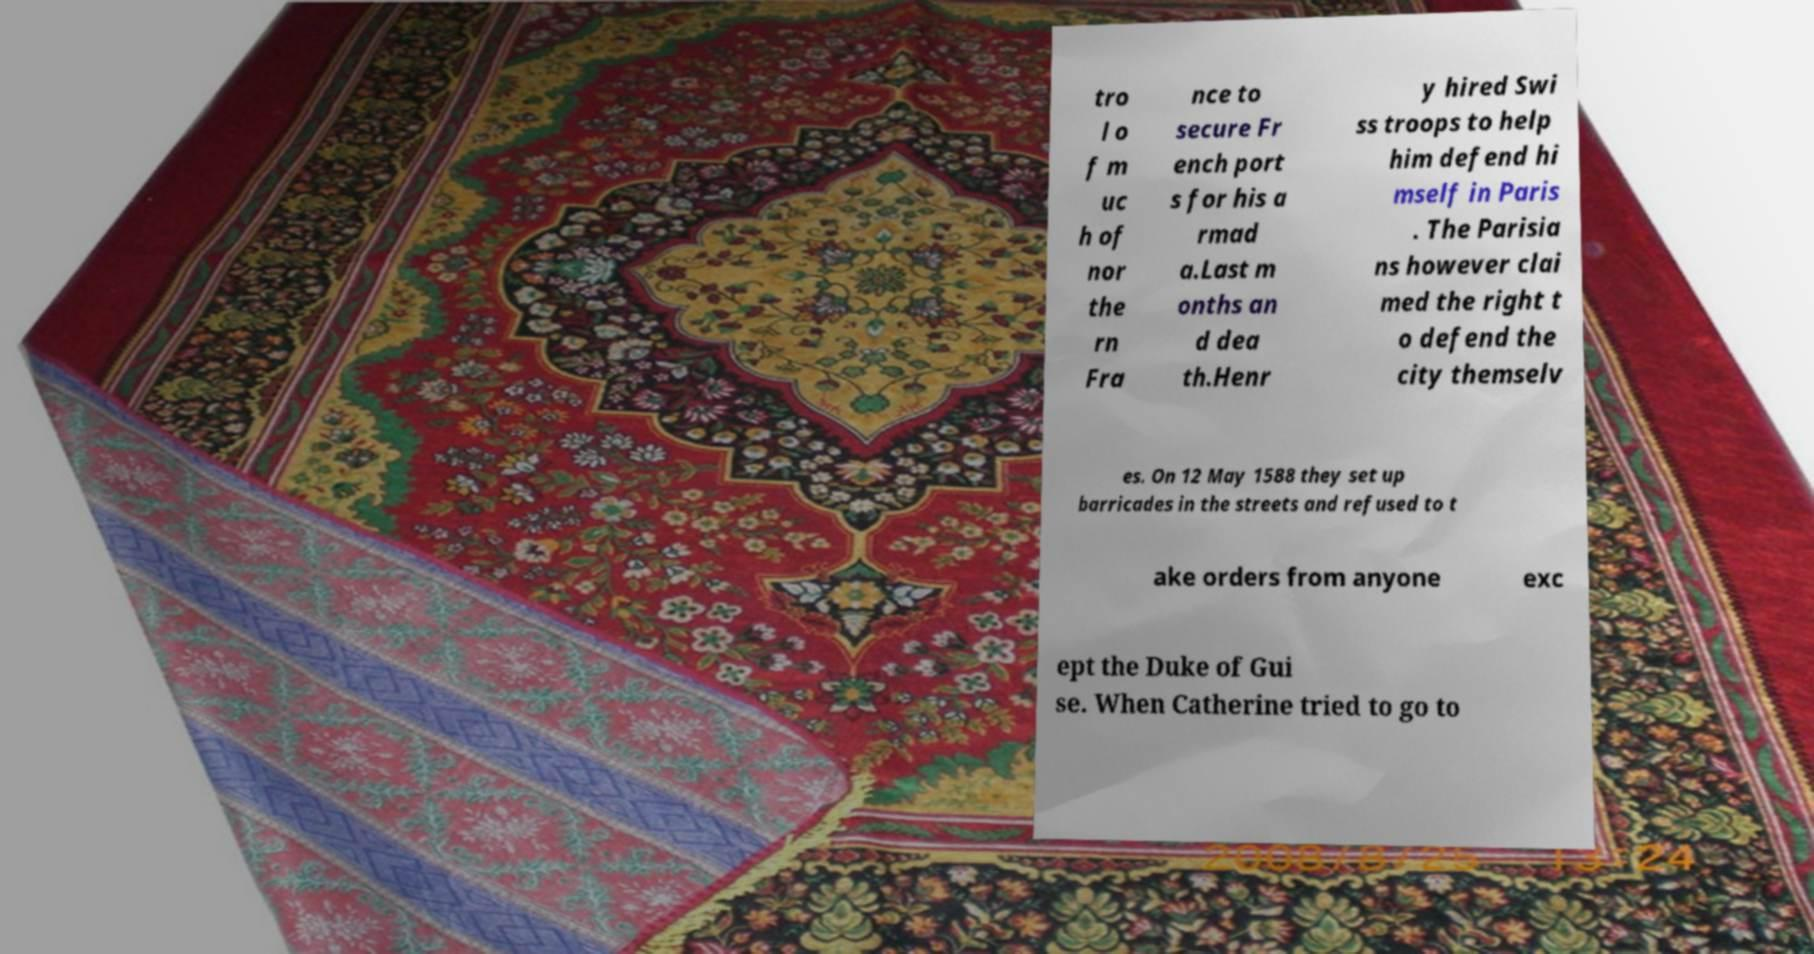What messages or text are displayed in this image? I need them in a readable, typed format. tro l o f m uc h of nor the rn Fra nce to secure Fr ench port s for his a rmad a.Last m onths an d dea th.Henr y hired Swi ss troops to help him defend hi mself in Paris . The Parisia ns however clai med the right t o defend the city themselv es. On 12 May 1588 they set up barricades in the streets and refused to t ake orders from anyone exc ept the Duke of Gui se. When Catherine tried to go to 